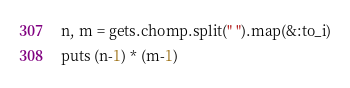Convert code to text. <code><loc_0><loc_0><loc_500><loc_500><_Ruby_>n, m = gets.chomp.split(" ").map(&:to_i)
puts (n-1) * (m-1)</code> 